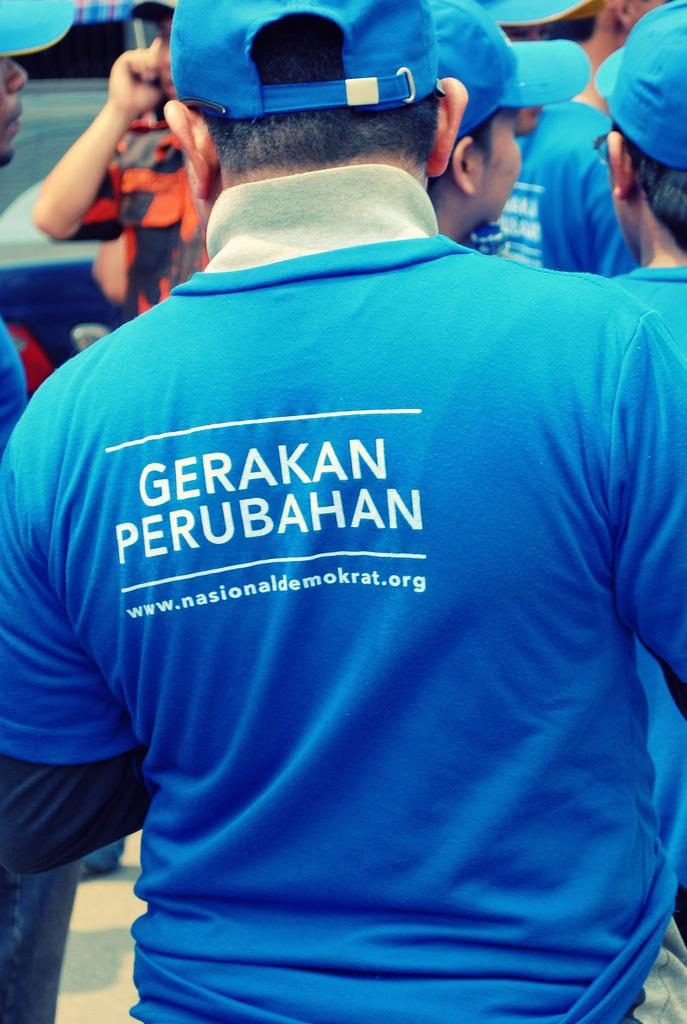<image>
Provide a brief description of the given image. A group of people wearing blue shirts with the words Gerakan Perubahan are standing next to each other. 